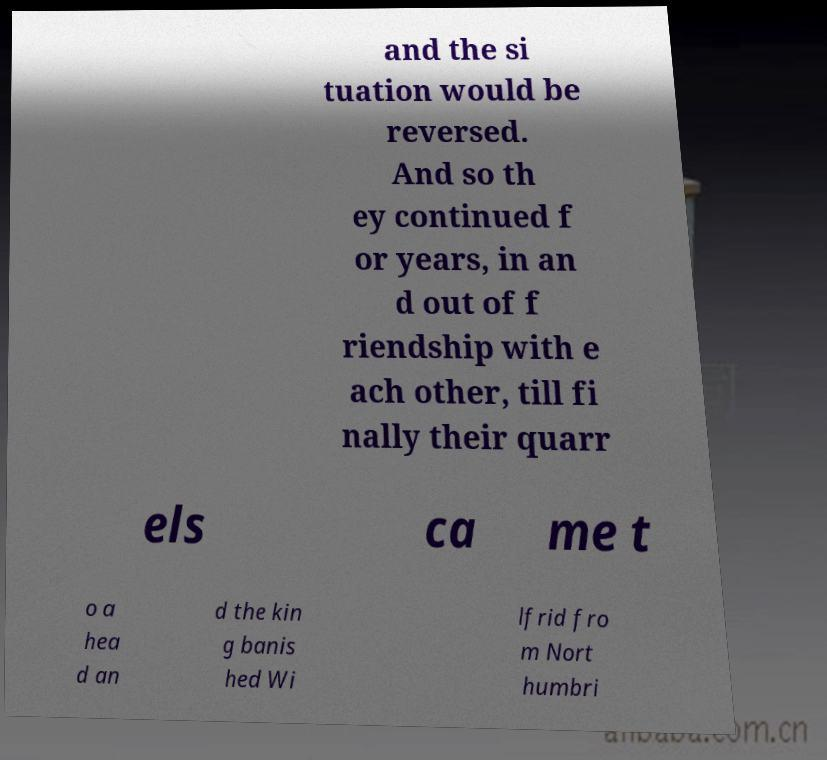Could you extract and type out the text from this image? and the si tuation would be reversed. And so th ey continued f or years, in an d out of f riendship with e ach other, till fi nally their quarr els ca me t o a hea d an d the kin g banis hed Wi lfrid fro m Nort humbri 